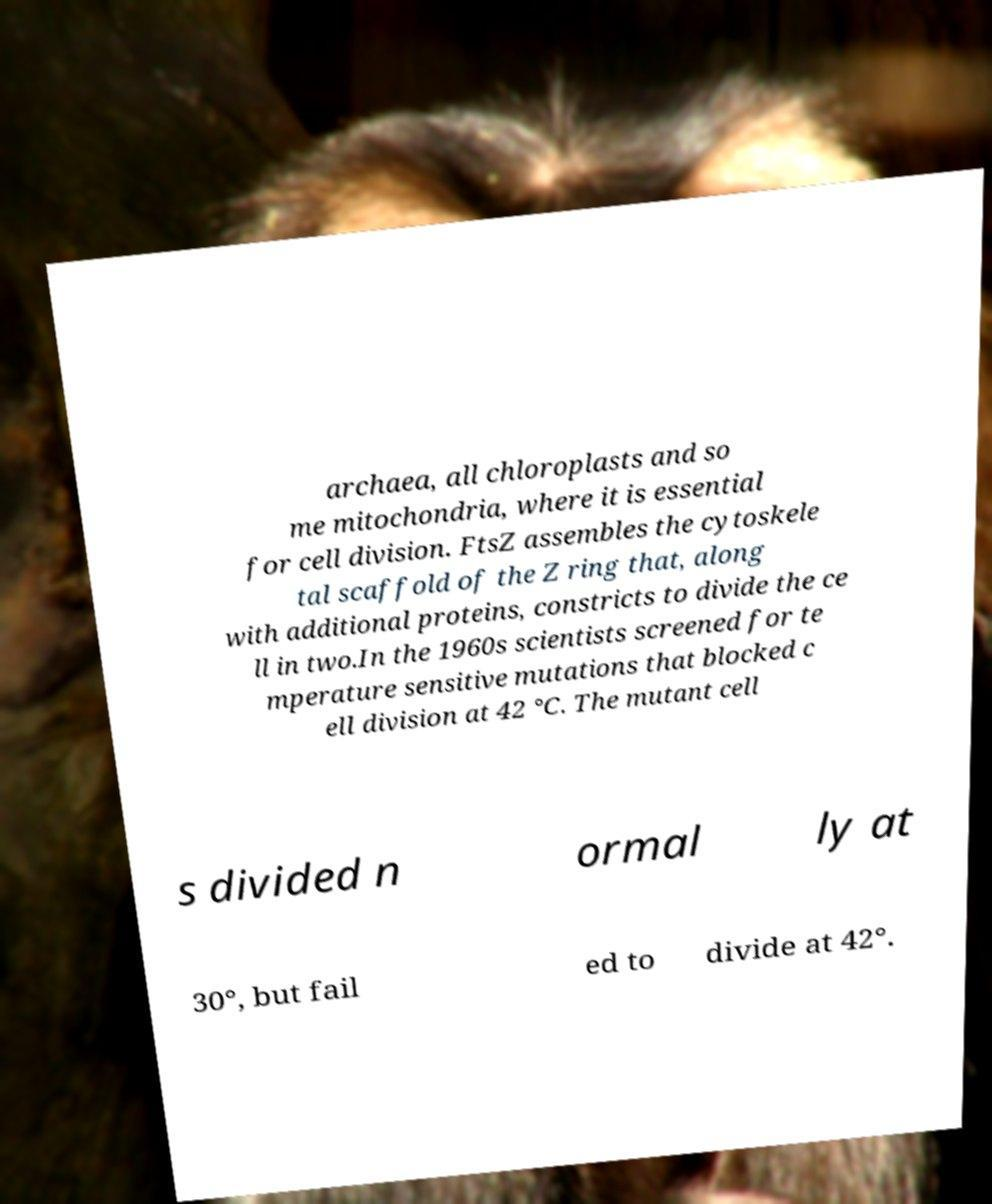Please read and relay the text visible in this image. What does it say? archaea, all chloroplasts and so me mitochondria, where it is essential for cell division. FtsZ assembles the cytoskele tal scaffold of the Z ring that, along with additional proteins, constricts to divide the ce ll in two.In the 1960s scientists screened for te mperature sensitive mutations that blocked c ell division at 42 °C. The mutant cell s divided n ormal ly at 30°, but fail ed to divide at 42°. 